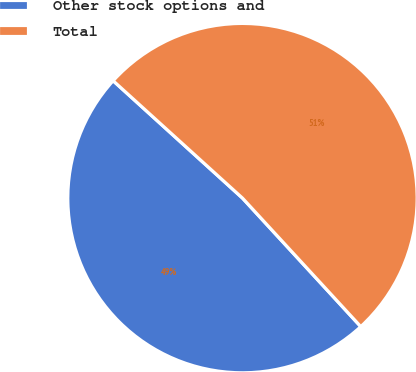Convert chart to OTSL. <chart><loc_0><loc_0><loc_500><loc_500><pie_chart><fcel>Other stock options and<fcel>Total<nl><fcel>48.57%<fcel>51.43%<nl></chart> 